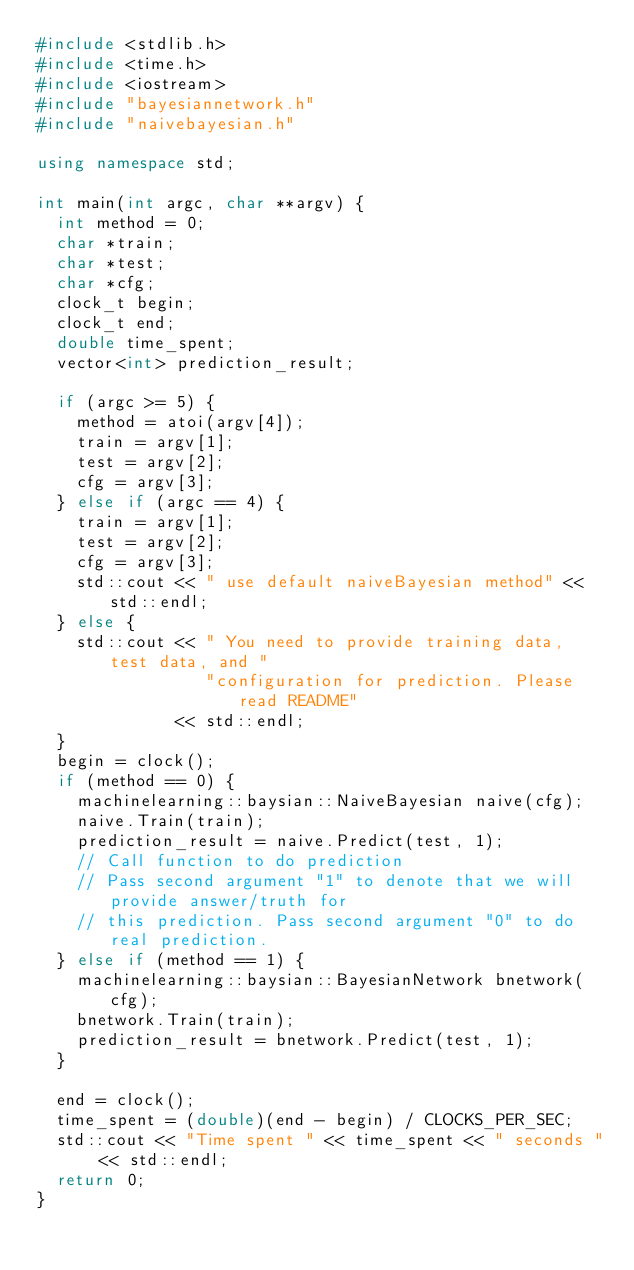<code> <loc_0><loc_0><loc_500><loc_500><_C++_>#include <stdlib.h>
#include <time.h>
#include <iostream>
#include "bayesiannetwork.h"
#include "naivebayesian.h"

using namespace std;

int main(int argc, char **argv) {
  int method = 0;
  char *train;
  char *test;
  char *cfg;
  clock_t begin;
  clock_t end;
  double time_spent;
  vector<int> prediction_result;

  if (argc >= 5) {
    method = atoi(argv[4]);
    train = argv[1];
    test = argv[2];
    cfg = argv[3];
  } else if (argc == 4) {
    train = argv[1];
    test = argv[2];
    cfg = argv[3];
    std::cout << " use default naiveBayesian method" << std::endl;
  } else {
    std::cout << " You need to provide training data, test data, and "
                 "configuration for prediction. Please read README"
              << std::endl;
  }
  begin = clock();
  if (method == 0) {
    machinelearning::baysian::NaiveBayesian naive(cfg);
    naive.Train(train);
    prediction_result = naive.Predict(test, 1);
    // Call function to do prediction
    // Pass second argument "1" to denote that we will provide answer/truth for
    // this prediction. Pass second argument "0" to do real prediction.
  } else if (method == 1) {
    machinelearning::baysian::BayesianNetwork bnetwork(cfg);
    bnetwork.Train(train);
    prediction_result = bnetwork.Predict(test, 1);
  }

  end = clock();
  time_spent = (double)(end - begin) / CLOCKS_PER_SEC;
  std::cout << "Time spent " << time_spent << " seconds " << std::endl;
  return 0;
}
</code> 